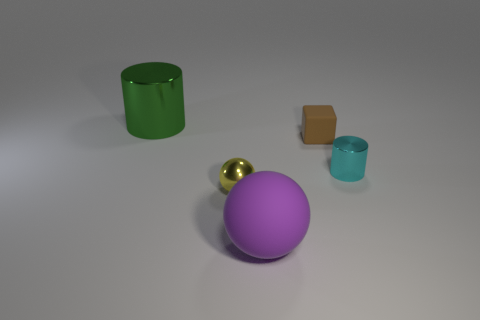Subtract all cyan cylinders. How many cylinders are left? 1 Subtract all cubes. How many objects are left? 4 Add 2 yellow things. How many yellow things are left? 3 Add 2 small metal cylinders. How many small metal cylinders exist? 3 Add 1 rubber spheres. How many objects exist? 6 Subtract 0 yellow cubes. How many objects are left? 5 Subtract 2 balls. How many balls are left? 0 Subtract all green cylinders. Subtract all yellow spheres. How many cylinders are left? 1 Subtract all yellow blocks. How many blue spheres are left? 0 Subtract all metallic balls. Subtract all tiny green metallic things. How many objects are left? 4 